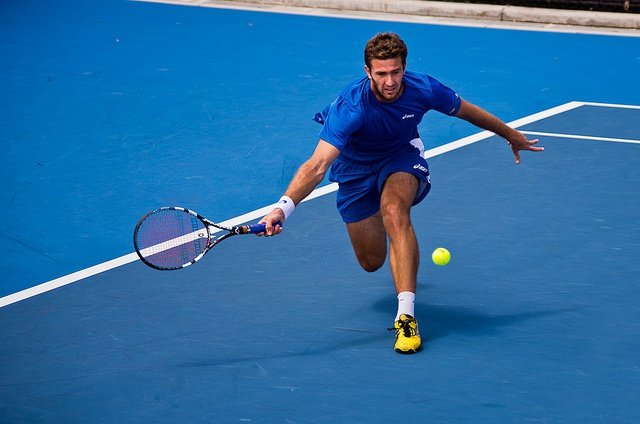Describe the objects in this image and their specific colors. I can see people in darkblue, navy, black, maroon, and blue tones, tennis racket in darkblue, blue, gray, lightgray, and black tones, and sports ball in darkblue, yellow, khaki, and lime tones in this image. 